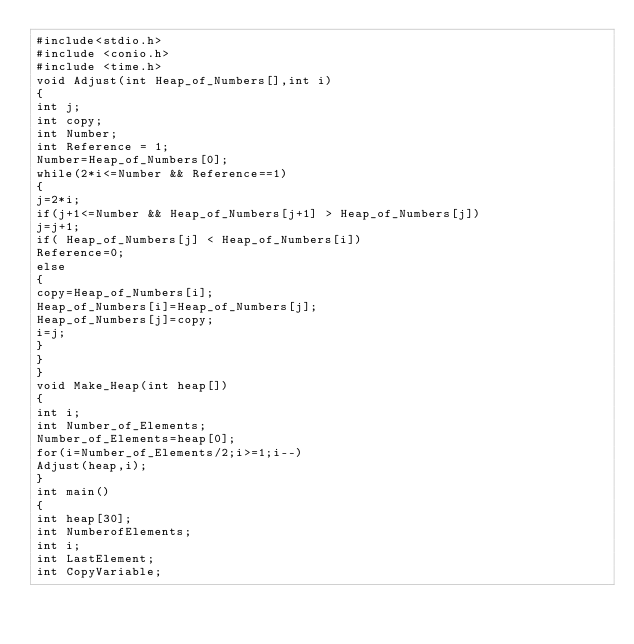Convert code to text. <code><loc_0><loc_0><loc_500><loc_500><_C_>#include<stdio.h>
#include <conio.h>
#include <time.h>
void Adjust(int Heap_of_Numbers[],int i)
{
int j;
int copy;
int Number;
int Reference = 1;
Number=Heap_of_Numbers[0];
while(2*i<=Number && Reference==1)
{
j=2*i;   
if(j+1<=Number && Heap_of_Numbers[j+1] > Heap_of_Numbers[j])
j=j+1;
if( Heap_of_Numbers[j] < Heap_of_Numbers[i])
Reference=0;
else
{
copy=Heap_of_Numbers[i];
Heap_of_Numbers[i]=Heap_of_Numbers[j];
Heap_of_Numbers[j]=copy;
i=j;
}
}
}
void Make_Heap(int heap[])
{
int i;
int Number_of_Elements;
Number_of_Elements=heap[0];
for(i=Number_of_Elements/2;i>=1;i--)
Adjust(heap,i);
}
int main()
{
int heap[30];
int NumberofElements;
int i;
int LastElement;
int CopyVariable;</code> 